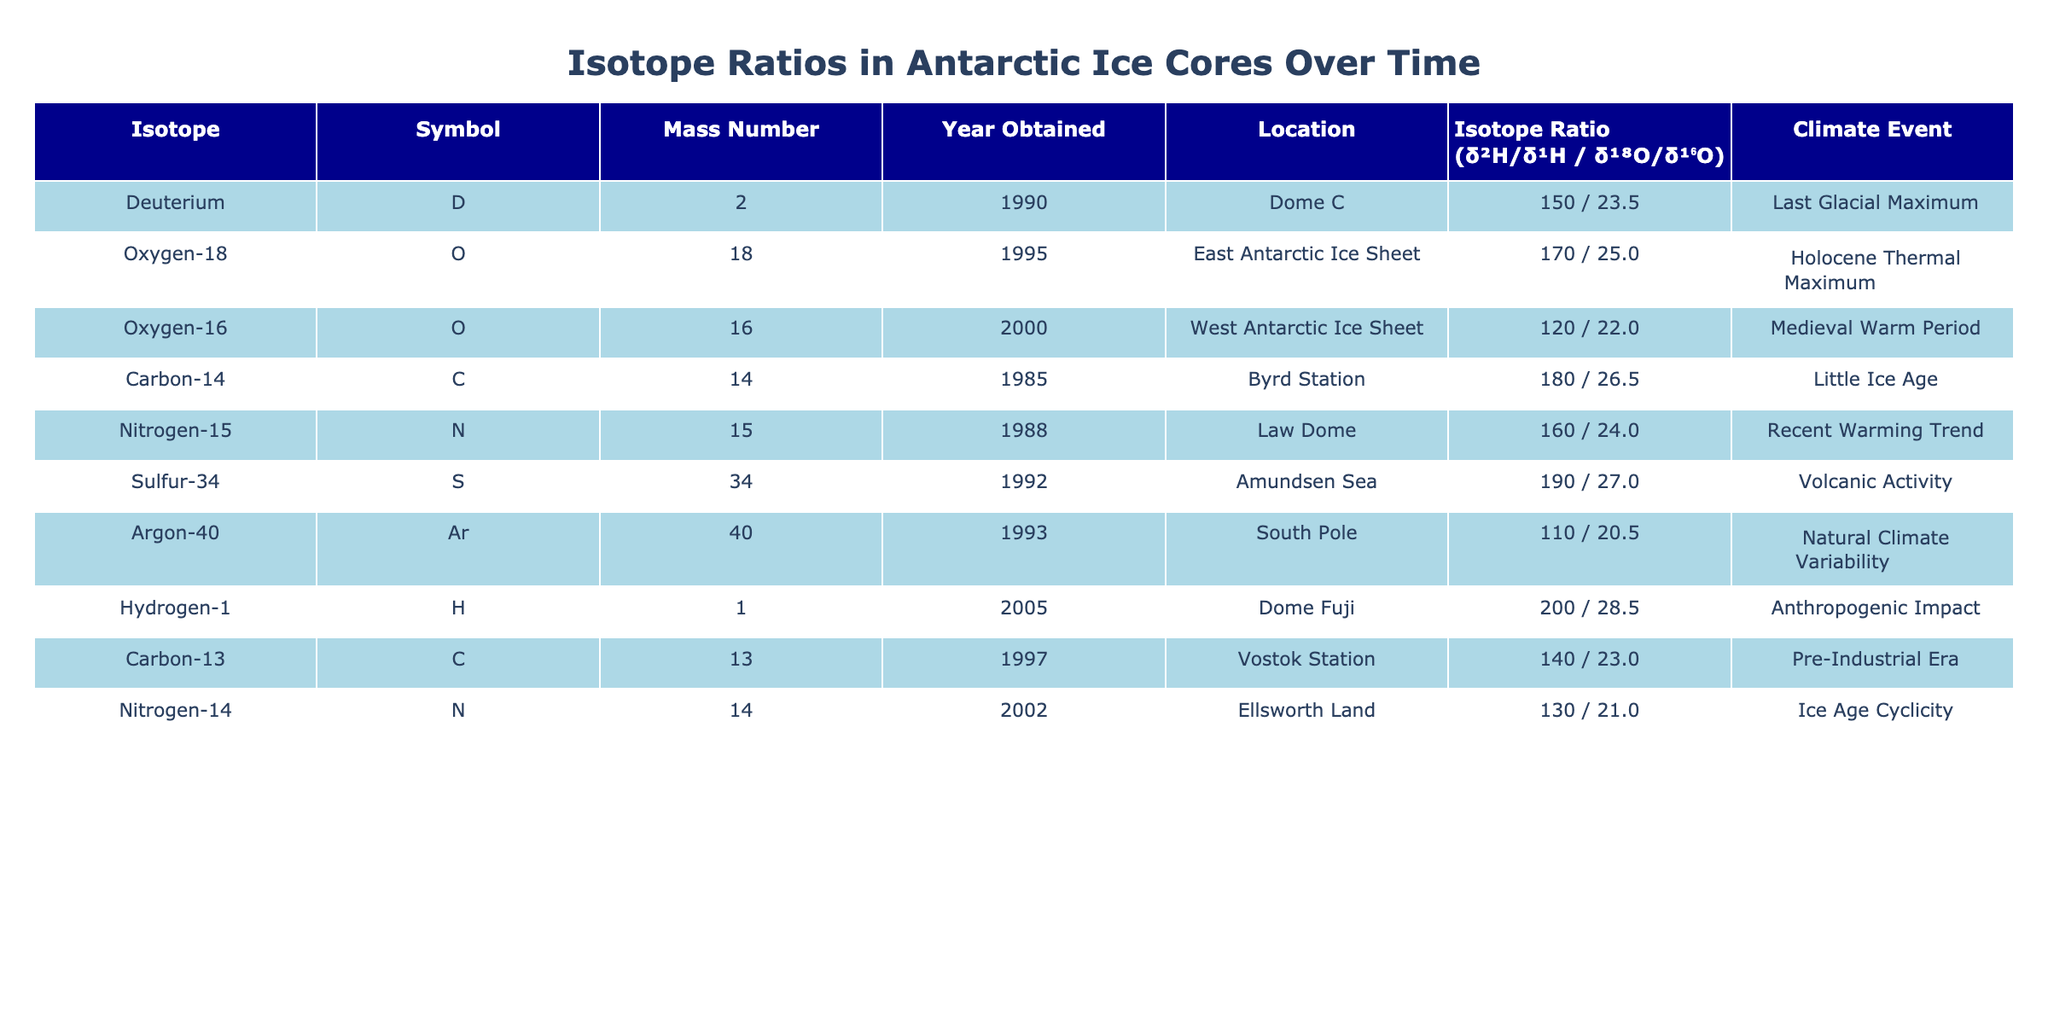What isotope has the highest ratio for δ²H/δ¹H? By looking at the "Isotope Ratio (δ²H/δ¹H)" column, I can see that the highest value is +200, which corresponds to Hydrogen-1 obtained in 2005.
Answer: Hydrogen-1 Which climate event is associated with the isotope obtained in 1995? From the "Year Obtained" column, the isotope obtained in 1995 is Oxygen-18. Checking the "Climate Event" column for this row shows it is associated with the Holocene Thermal Maximum.
Answer: Holocene Thermal Maximum What is the isotope ratio for Deuterium? From the "Deuterium" row, the table shows that the isotope ratios are +150 (δ²H/δ¹H) and +23.5 (δ¹⁸O/δ¹⁶O). Combining these, the isotope ratio is +150 / +23.5.
Answer: +150 / +23.5 Is there any isotope related to volcanic activity? Checking the "Climate Event" column, I see that Sulfur-34, obtained in 1992, is associated with volcanic activity. Therefore, yes, there is an isotope related to volcanic activity.
Answer: Yes What is the average isotope ratio (δ¹⁸O/δ¹⁶O) for isotopes associated with climate events before 2000? For events before 2000, I look at the rows for Deuterium, Carbon-14, Nitrogen-15, and Argon-40. Their δ¹⁸O/δ¹⁶O values are 23.5, 26.5, 24.0, and 20.5 respectively. The sum is 23.5 + 26.5 + 24.0 + 20.5 = 94.5. There are four data points, so the average is 94.5 / 4 = 23.625.
Answer: 23.625 Which isotope has the lowest δ¹⁸O/δ¹⁶O ratio? From the "Isotope Ratio (δ¹⁸O/δ¹⁶O)" column, I can see the lowest ratio is +20.5 corresponding to Argon-40.
Answer: Argon-40 